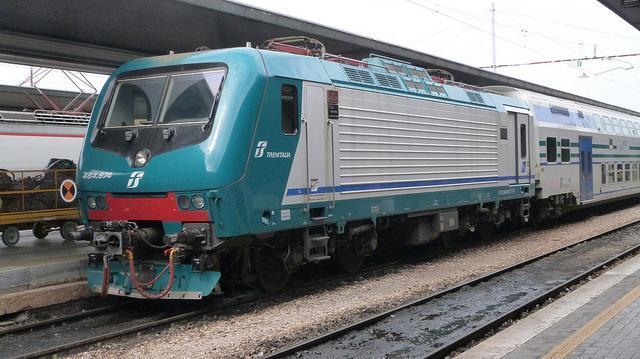How many tracks are there?
Give a very brief answer. 2. How many trains are there?
Give a very brief answer. 2. 